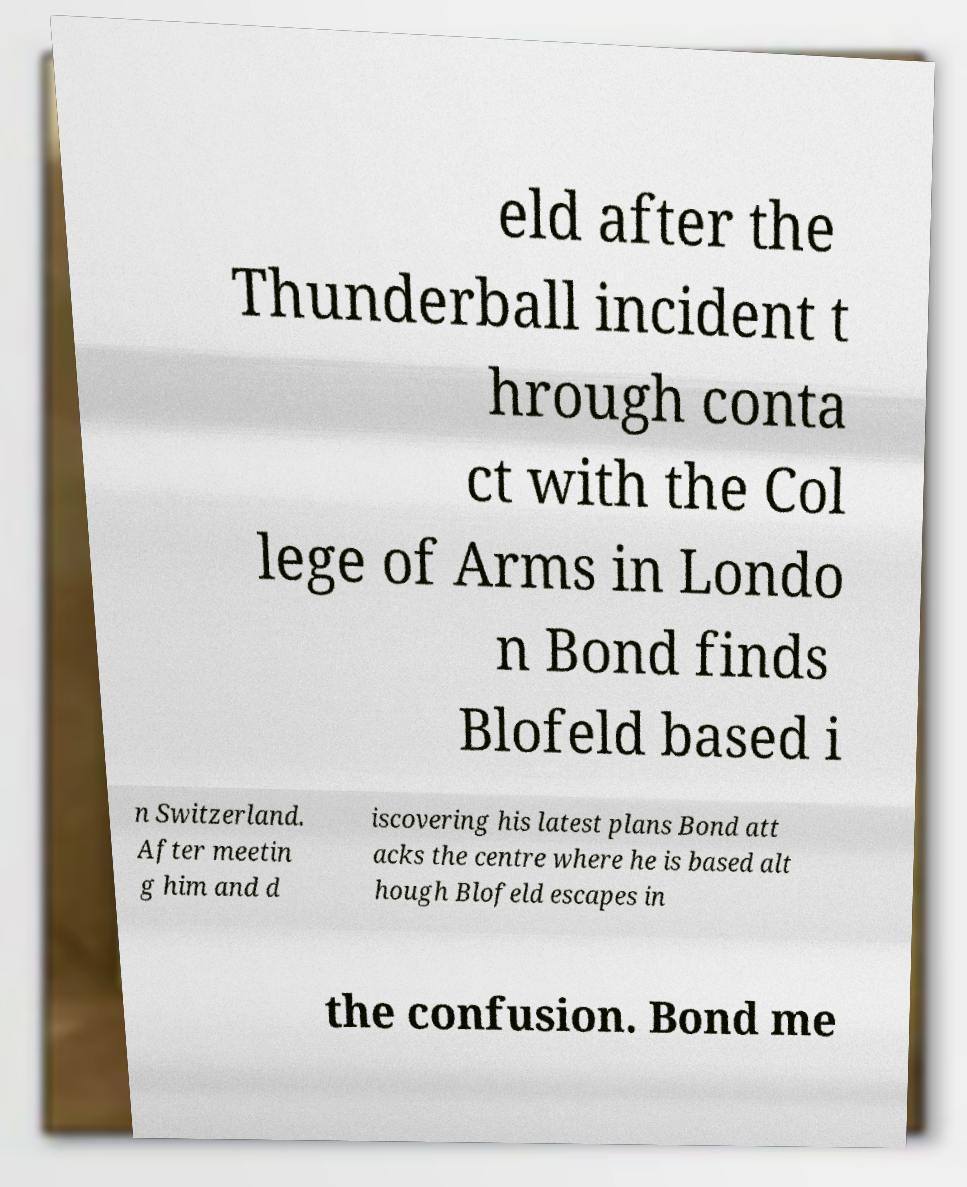Please read and relay the text visible in this image. What does it say? eld after the Thunderball incident t hrough conta ct with the Col lege of Arms in Londo n Bond finds Blofeld based i n Switzerland. After meetin g him and d iscovering his latest plans Bond att acks the centre where he is based alt hough Blofeld escapes in the confusion. Bond me 